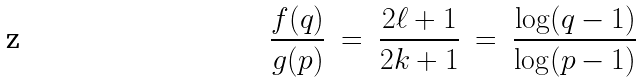Convert formula to latex. <formula><loc_0><loc_0><loc_500><loc_500>\frac { f ( q ) } { g ( p ) } \text { } = \text { } \frac { 2 \ell + 1 } { 2 k + 1 } \text {   } = \text { } \frac { \log ( q - 1 ) } { \log ( p - 1 ) }</formula> 